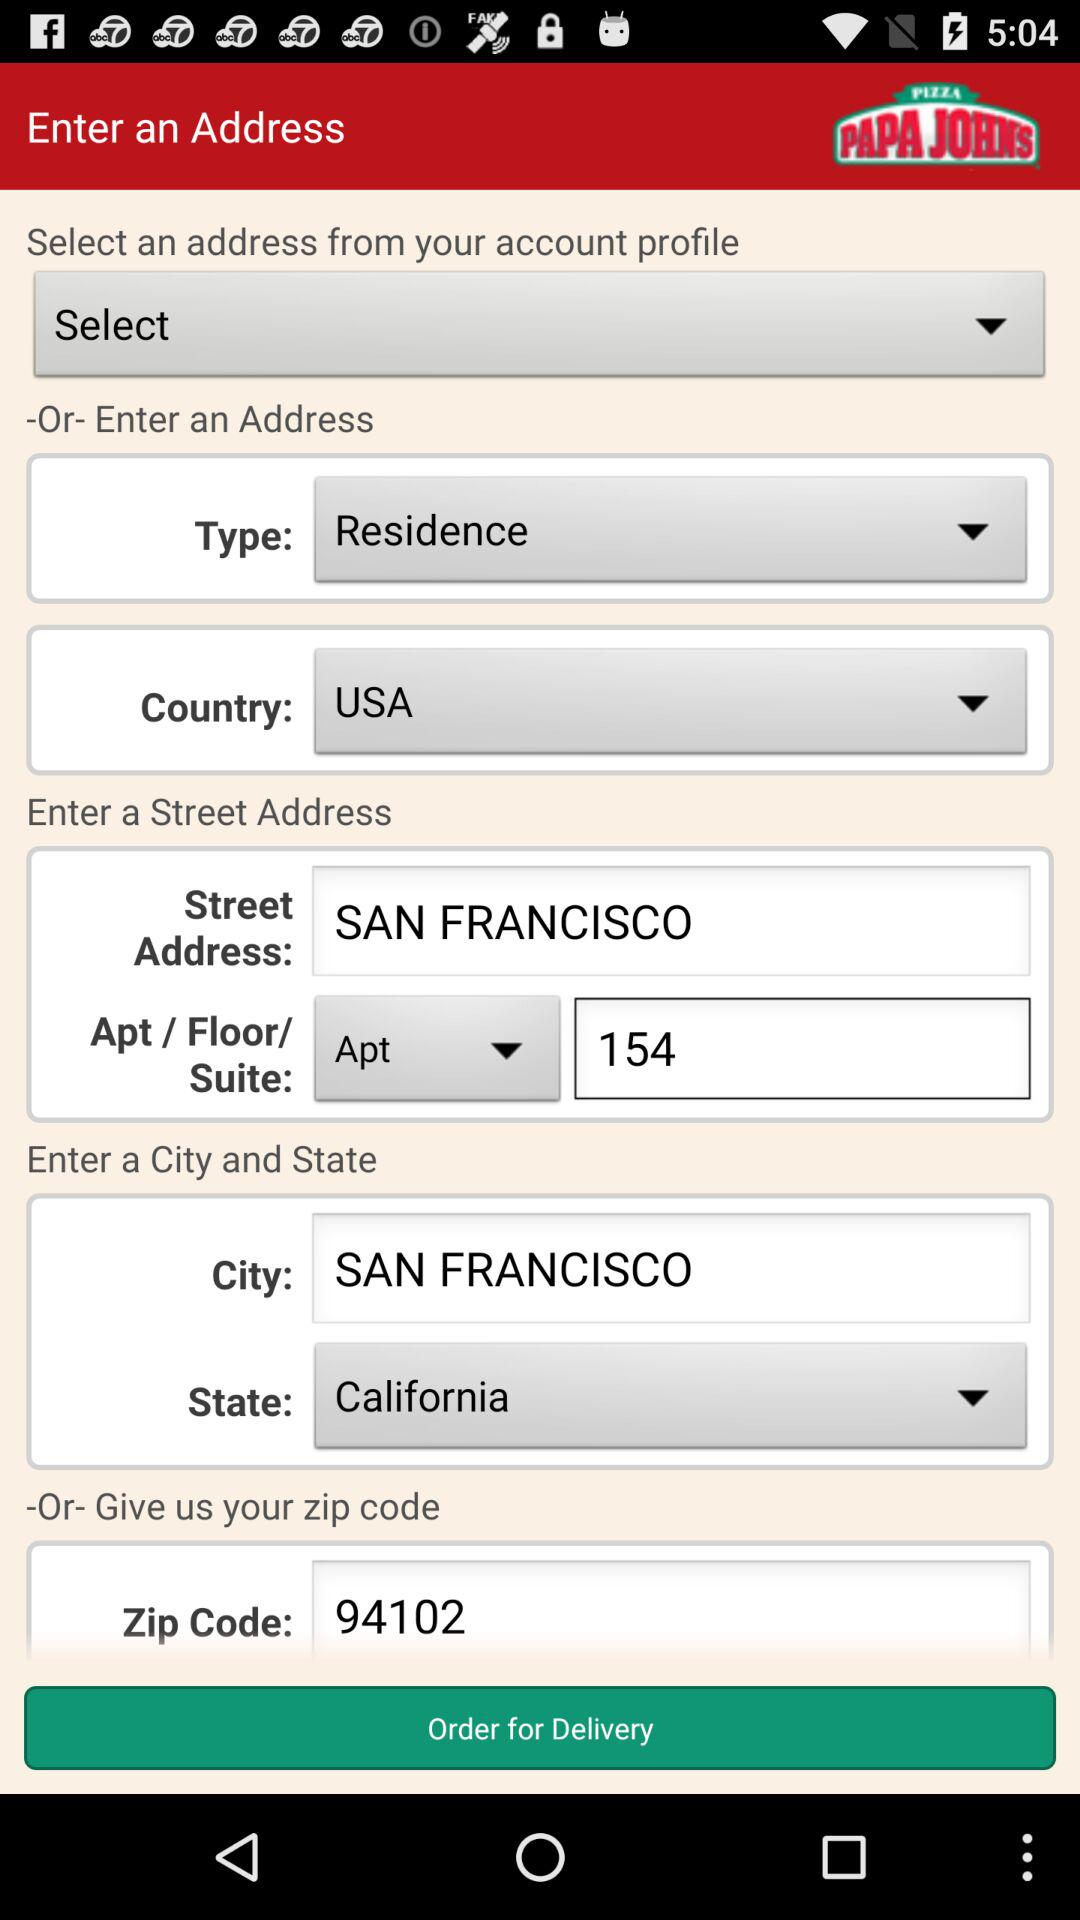Which is the selected address type? The selected address type is "Residence". 